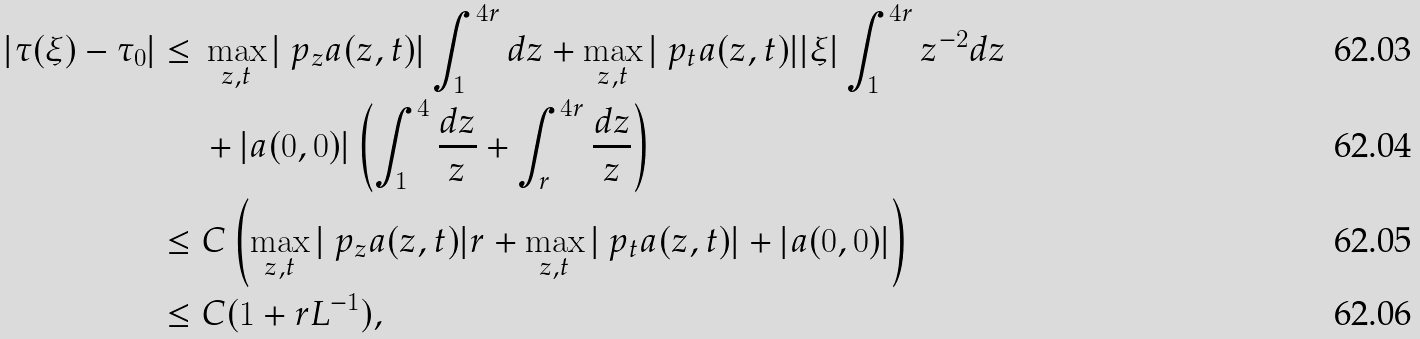<formula> <loc_0><loc_0><loc_500><loc_500>| \tau ( \xi ) - \tau _ { 0 } | \leq & \ \max _ { z , t } | \ p _ { z } a ( z , t ) | \int _ { 1 } ^ { 4 r } d z + \max _ { z , t } | \ p _ { t } a ( z , t ) | | \xi | \int _ { 1 } ^ { 4 r } z ^ { - 2 } d z \\ & \ + | a ( 0 , 0 ) | \left ( \int _ { 1 } ^ { 4 } \frac { d z } { z } + \int _ { r } ^ { 4 r } \frac { d z } { z } \right ) \\ \leq & \ C \left ( \max _ { z , t } | \ p _ { z } a ( z , t ) | r + \max _ { z , t } | \ p _ { t } a ( z , t ) | + | a ( 0 , 0 ) | \right ) \\ \leq & \ C ( 1 + r L ^ { - 1 } ) ,</formula> 